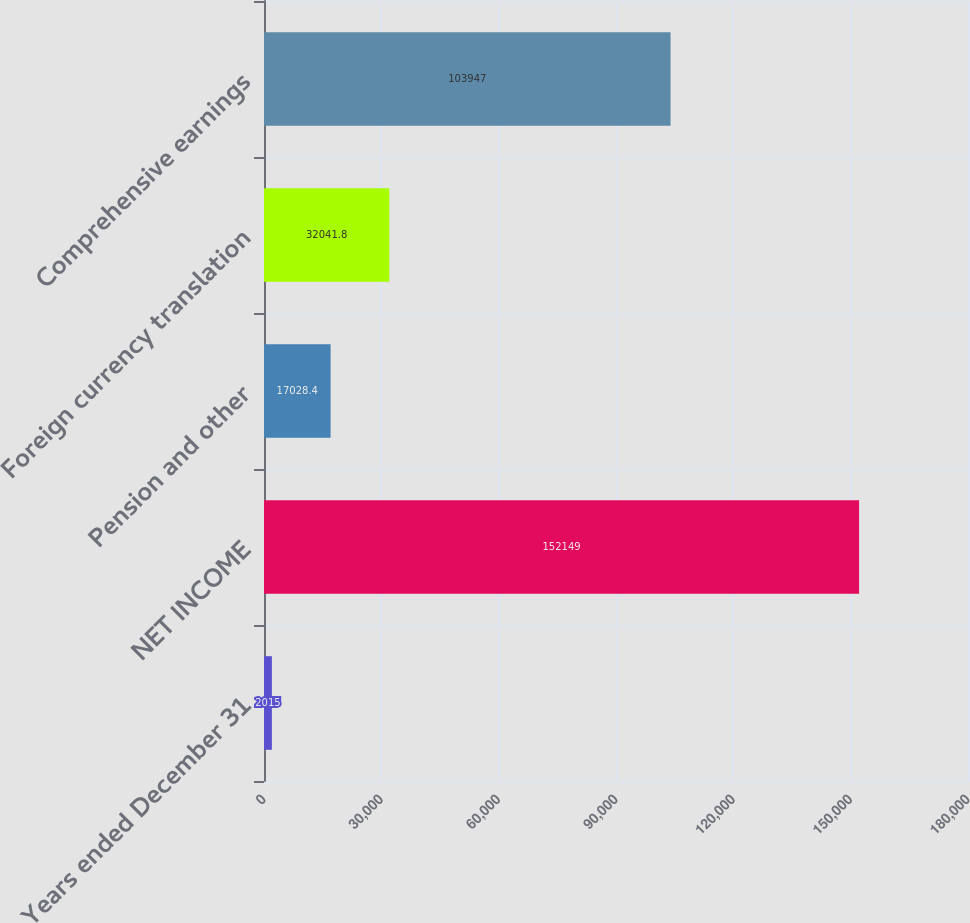<chart> <loc_0><loc_0><loc_500><loc_500><bar_chart><fcel>Years ended December 31<fcel>NET INCOME<fcel>Pension and other<fcel>Foreign currency translation<fcel>Comprehensive earnings<nl><fcel>2015<fcel>152149<fcel>17028.4<fcel>32041.8<fcel>103947<nl></chart> 